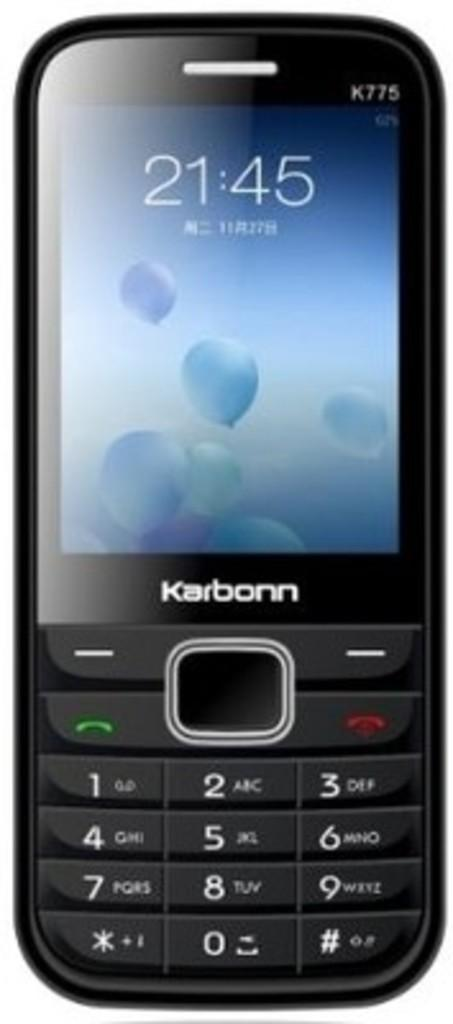<image>
Offer a succinct explanation of the picture presented. black phone by the brand karbonn is turned on 